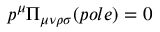<formula> <loc_0><loc_0><loc_500><loc_500>p ^ { \mu } \Pi _ { \mu \nu \rho \sigma } ( p o l e ) = 0</formula> 